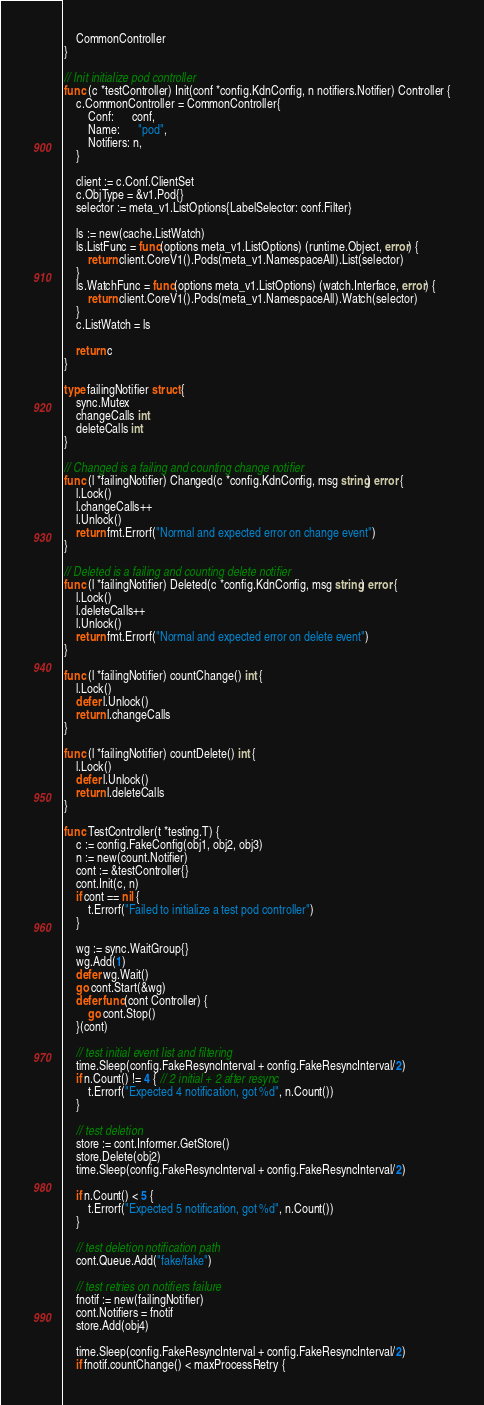<code> <loc_0><loc_0><loc_500><loc_500><_Go_>	CommonController
}

// Init initialize pod controller
func (c *testController) Init(conf *config.KdnConfig, n notifiers.Notifier) Controller {
	c.CommonController = CommonController{
		Conf:      conf,
		Name:      "pod",
		Notifiers: n,
	}

	client := c.Conf.ClientSet
	c.ObjType = &v1.Pod{}
	selector := meta_v1.ListOptions{LabelSelector: conf.Filter}

	ls := new(cache.ListWatch)
	ls.ListFunc = func(options meta_v1.ListOptions) (runtime.Object, error) {
		return client.CoreV1().Pods(meta_v1.NamespaceAll).List(selector)
	}
	ls.WatchFunc = func(options meta_v1.ListOptions) (watch.Interface, error) {
		return client.CoreV1().Pods(meta_v1.NamespaceAll).Watch(selector)
	}
	c.ListWatch = ls

	return c
}

type failingNotifier struct {
	sync.Mutex
	changeCalls int
	deleteCalls int
}

// Changed is a failing and counting change notifier
func (l *failingNotifier) Changed(c *config.KdnConfig, msg string) error {
	l.Lock()
	l.changeCalls++
	l.Unlock()
	return fmt.Errorf("Normal and expected error on change event")
}

// Deleted is a failing and counting delete notifier
func (l *failingNotifier) Deleted(c *config.KdnConfig, msg string) error {
	l.Lock()
	l.deleteCalls++
	l.Unlock()
	return fmt.Errorf("Normal and expected error on delete event")
}

func (l *failingNotifier) countChange() int {
	l.Lock()
	defer l.Unlock()
	return l.changeCalls
}

func (l *failingNotifier) countDelete() int {
	l.Lock()
	defer l.Unlock()
	return l.deleteCalls
}

func TestController(t *testing.T) {
	c := config.FakeConfig(obj1, obj2, obj3)
	n := new(count.Notifier)
	cont := &testController{}
	cont.Init(c, n)
	if cont == nil {
		t.Errorf("Failed to initialize a test pod controller")
	}

	wg := sync.WaitGroup{}
	wg.Add(1)
	defer wg.Wait()
	go cont.Start(&wg)
	defer func(cont Controller) {
		go cont.Stop()
	}(cont)

	// test initial event list and filtering
	time.Sleep(config.FakeResyncInterval + config.FakeResyncInterval/2)
	if n.Count() != 4 { // 2 initial + 2 after resync
		t.Errorf("Expected 4 notification, got %d", n.Count())
	}

	// test deletion
	store := cont.Informer.GetStore()
	store.Delete(obj2)
	time.Sleep(config.FakeResyncInterval + config.FakeResyncInterval/2)

	if n.Count() < 5 {
		t.Errorf("Expected 5 notification, got %d", n.Count())
	}

	// test deletion notification path
	cont.Queue.Add("fake/fake")

	// test retries on notifiers failure
	fnotif := new(failingNotifier)
	cont.Notifiers = fnotif
	store.Add(obj4)

	time.Sleep(config.FakeResyncInterval + config.FakeResyncInterval/2)
	if fnotif.countChange() < maxProcessRetry {</code> 